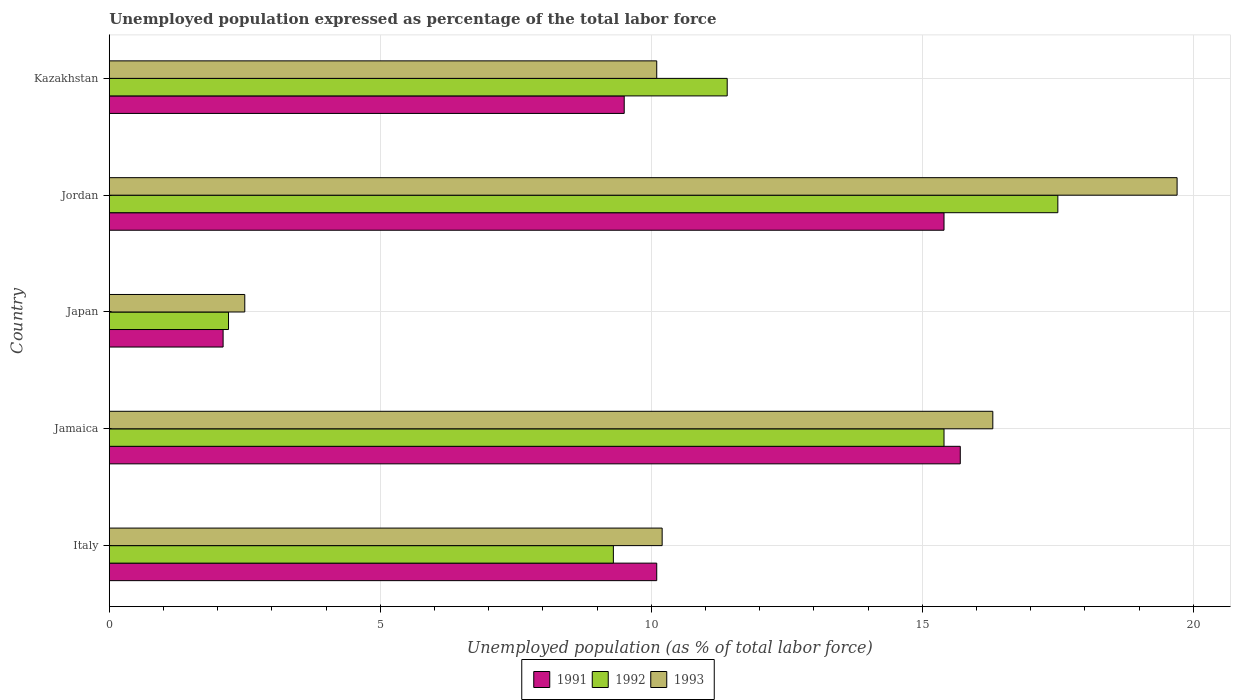How many different coloured bars are there?
Your answer should be compact. 3. How many groups of bars are there?
Keep it short and to the point. 5. Are the number of bars per tick equal to the number of legend labels?
Your response must be concise. Yes. Are the number of bars on each tick of the Y-axis equal?
Provide a short and direct response. Yes. How many bars are there on the 4th tick from the top?
Provide a succinct answer. 3. How many bars are there on the 3rd tick from the bottom?
Provide a short and direct response. 3. What is the label of the 1st group of bars from the top?
Keep it short and to the point. Kazakhstan. In how many cases, is the number of bars for a given country not equal to the number of legend labels?
Keep it short and to the point. 0. What is the unemployment in in 1991 in Italy?
Keep it short and to the point. 10.1. Across all countries, what is the maximum unemployment in in 1991?
Your answer should be compact. 15.7. Across all countries, what is the minimum unemployment in in 1991?
Provide a succinct answer. 2.1. In which country was the unemployment in in 1991 maximum?
Offer a terse response. Jamaica. What is the total unemployment in in 1992 in the graph?
Give a very brief answer. 55.8. What is the difference between the unemployment in in 1993 in Italy and that in Japan?
Keep it short and to the point. 7.7. What is the difference between the unemployment in in 1991 in Italy and the unemployment in in 1993 in Japan?
Provide a short and direct response. 7.6. What is the average unemployment in in 1993 per country?
Make the answer very short. 11.76. What is the difference between the unemployment in in 1992 and unemployment in in 1991 in Jamaica?
Offer a very short reply. -0.3. What is the ratio of the unemployment in in 1992 in Italy to that in Kazakhstan?
Offer a very short reply. 0.82. Is the unemployment in in 1992 in Japan less than that in Kazakhstan?
Offer a terse response. Yes. What is the difference between the highest and the second highest unemployment in in 1992?
Make the answer very short. 2.1. What is the difference between the highest and the lowest unemployment in in 1991?
Provide a short and direct response. 13.6. In how many countries, is the unemployment in in 1993 greater than the average unemployment in in 1993 taken over all countries?
Ensure brevity in your answer.  2. Is the sum of the unemployment in in 1991 in Japan and Jordan greater than the maximum unemployment in in 1992 across all countries?
Your answer should be very brief. No. What does the 3rd bar from the bottom in Kazakhstan represents?
Make the answer very short. 1993. Is it the case that in every country, the sum of the unemployment in in 1993 and unemployment in in 1992 is greater than the unemployment in in 1991?
Offer a very short reply. Yes. How many bars are there?
Make the answer very short. 15. Are all the bars in the graph horizontal?
Your response must be concise. Yes. How many countries are there in the graph?
Your answer should be very brief. 5. Does the graph contain any zero values?
Your response must be concise. No. Does the graph contain grids?
Give a very brief answer. Yes. Where does the legend appear in the graph?
Give a very brief answer. Bottom center. How many legend labels are there?
Make the answer very short. 3. How are the legend labels stacked?
Provide a succinct answer. Horizontal. What is the title of the graph?
Provide a short and direct response. Unemployed population expressed as percentage of the total labor force. Does "1986" appear as one of the legend labels in the graph?
Provide a succinct answer. No. What is the label or title of the X-axis?
Your answer should be compact. Unemployed population (as % of total labor force). What is the label or title of the Y-axis?
Keep it short and to the point. Country. What is the Unemployed population (as % of total labor force) of 1991 in Italy?
Offer a very short reply. 10.1. What is the Unemployed population (as % of total labor force) of 1992 in Italy?
Give a very brief answer. 9.3. What is the Unemployed population (as % of total labor force) of 1993 in Italy?
Your answer should be very brief. 10.2. What is the Unemployed population (as % of total labor force) in 1991 in Jamaica?
Offer a terse response. 15.7. What is the Unemployed population (as % of total labor force) in 1992 in Jamaica?
Provide a succinct answer. 15.4. What is the Unemployed population (as % of total labor force) in 1993 in Jamaica?
Provide a succinct answer. 16.3. What is the Unemployed population (as % of total labor force) in 1991 in Japan?
Ensure brevity in your answer.  2.1. What is the Unemployed population (as % of total labor force) in 1992 in Japan?
Offer a terse response. 2.2. What is the Unemployed population (as % of total labor force) in 1991 in Jordan?
Offer a very short reply. 15.4. What is the Unemployed population (as % of total labor force) in 1992 in Jordan?
Offer a terse response. 17.5. What is the Unemployed population (as % of total labor force) in 1993 in Jordan?
Your answer should be compact. 19.7. What is the Unemployed population (as % of total labor force) of 1991 in Kazakhstan?
Keep it short and to the point. 9.5. What is the Unemployed population (as % of total labor force) of 1992 in Kazakhstan?
Offer a terse response. 11.4. What is the Unemployed population (as % of total labor force) in 1993 in Kazakhstan?
Keep it short and to the point. 10.1. Across all countries, what is the maximum Unemployed population (as % of total labor force) of 1991?
Provide a succinct answer. 15.7. Across all countries, what is the maximum Unemployed population (as % of total labor force) in 1992?
Your answer should be very brief. 17.5. Across all countries, what is the maximum Unemployed population (as % of total labor force) of 1993?
Ensure brevity in your answer.  19.7. Across all countries, what is the minimum Unemployed population (as % of total labor force) of 1991?
Provide a succinct answer. 2.1. Across all countries, what is the minimum Unemployed population (as % of total labor force) in 1992?
Offer a terse response. 2.2. What is the total Unemployed population (as % of total labor force) in 1991 in the graph?
Provide a short and direct response. 52.8. What is the total Unemployed population (as % of total labor force) in 1992 in the graph?
Give a very brief answer. 55.8. What is the total Unemployed population (as % of total labor force) of 1993 in the graph?
Offer a very short reply. 58.8. What is the difference between the Unemployed population (as % of total labor force) in 1991 in Italy and that in Jamaica?
Give a very brief answer. -5.6. What is the difference between the Unemployed population (as % of total labor force) of 1991 in Italy and that in Japan?
Ensure brevity in your answer.  8. What is the difference between the Unemployed population (as % of total labor force) of 1992 in Italy and that in Japan?
Offer a terse response. 7.1. What is the difference between the Unemployed population (as % of total labor force) of 1992 in Italy and that in Kazakhstan?
Your answer should be very brief. -2.1. What is the difference between the Unemployed population (as % of total labor force) in 1993 in Italy and that in Kazakhstan?
Provide a succinct answer. 0.1. What is the difference between the Unemployed population (as % of total labor force) in 1991 in Jamaica and that in Japan?
Ensure brevity in your answer.  13.6. What is the difference between the Unemployed population (as % of total labor force) in 1993 in Jamaica and that in Japan?
Your response must be concise. 13.8. What is the difference between the Unemployed population (as % of total labor force) in 1992 in Jamaica and that in Kazakhstan?
Provide a short and direct response. 4. What is the difference between the Unemployed population (as % of total labor force) of 1992 in Japan and that in Jordan?
Your response must be concise. -15.3. What is the difference between the Unemployed population (as % of total labor force) in 1993 in Japan and that in Jordan?
Ensure brevity in your answer.  -17.2. What is the difference between the Unemployed population (as % of total labor force) of 1991 in Japan and that in Kazakhstan?
Your answer should be very brief. -7.4. What is the difference between the Unemployed population (as % of total labor force) in 1993 in Jordan and that in Kazakhstan?
Make the answer very short. 9.6. What is the difference between the Unemployed population (as % of total labor force) in 1991 in Italy and the Unemployed population (as % of total labor force) in 1992 in Jamaica?
Provide a succinct answer. -5.3. What is the difference between the Unemployed population (as % of total labor force) in 1991 in Italy and the Unemployed population (as % of total labor force) in 1993 in Jamaica?
Give a very brief answer. -6.2. What is the difference between the Unemployed population (as % of total labor force) of 1991 in Italy and the Unemployed population (as % of total labor force) of 1992 in Japan?
Your answer should be very brief. 7.9. What is the difference between the Unemployed population (as % of total labor force) in 1991 in Italy and the Unemployed population (as % of total labor force) in 1993 in Japan?
Your answer should be compact. 7.6. What is the difference between the Unemployed population (as % of total labor force) of 1992 in Italy and the Unemployed population (as % of total labor force) of 1993 in Japan?
Provide a succinct answer. 6.8. What is the difference between the Unemployed population (as % of total labor force) in 1991 in Italy and the Unemployed population (as % of total labor force) in 1992 in Jordan?
Offer a very short reply. -7.4. What is the difference between the Unemployed population (as % of total labor force) of 1992 in Italy and the Unemployed population (as % of total labor force) of 1993 in Jordan?
Provide a short and direct response. -10.4. What is the difference between the Unemployed population (as % of total labor force) in 1991 in Italy and the Unemployed population (as % of total labor force) in 1993 in Kazakhstan?
Make the answer very short. 0. What is the difference between the Unemployed population (as % of total labor force) in 1991 in Jamaica and the Unemployed population (as % of total labor force) in 1993 in Japan?
Offer a very short reply. 13.2. What is the difference between the Unemployed population (as % of total labor force) in 1992 in Jamaica and the Unemployed population (as % of total labor force) in 1993 in Japan?
Offer a terse response. 12.9. What is the difference between the Unemployed population (as % of total labor force) in 1991 in Jamaica and the Unemployed population (as % of total labor force) in 1993 in Jordan?
Your answer should be compact. -4. What is the difference between the Unemployed population (as % of total labor force) of 1992 in Jamaica and the Unemployed population (as % of total labor force) of 1993 in Jordan?
Keep it short and to the point. -4.3. What is the difference between the Unemployed population (as % of total labor force) in 1992 in Jamaica and the Unemployed population (as % of total labor force) in 1993 in Kazakhstan?
Provide a short and direct response. 5.3. What is the difference between the Unemployed population (as % of total labor force) of 1991 in Japan and the Unemployed population (as % of total labor force) of 1992 in Jordan?
Your answer should be very brief. -15.4. What is the difference between the Unemployed population (as % of total labor force) in 1991 in Japan and the Unemployed population (as % of total labor force) in 1993 in Jordan?
Give a very brief answer. -17.6. What is the difference between the Unemployed population (as % of total labor force) in 1992 in Japan and the Unemployed population (as % of total labor force) in 1993 in Jordan?
Make the answer very short. -17.5. What is the difference between the Unemployed population (as % of total labor force) in 1991 in Japan and the Unemployed population (as % of total labor force) in 1993 in Kazakhstan?
Provide a succinct answer. -8. What is the difference between the Unemployed population (as % of total labor force) in 1991 in Jordan and the Unemployed population (as % of total labor force) in 1992 in Kazakhstan?
Your answer should be compact. 4. What is the difference between the Unemployed population (as % of total labor force) in 1992 in Jordan and the Unemployed population (as % of total labor force) in 1993 in Kazakhstan?
Provide a short and direct response. 7.4. What is the average Unemployed population (as % of total labor force) of 1991 per country?
Offer a very short reply. 10.56. What is the average Unemployed population (as % of total labor force) in 1992 per country?
Your answer should be very brief. 11.16. What is the average Unemployed population (as % of total labor force) in 1993 per country?
Your answer should be very brief. 11.76. What is the difference between the Unemployed population (as % of total labor force) of 1991 and Unemployed population (as % of total labor force) of 1992 in Italy?
Offer a terse response. 0.8. What is the difference between the Unemployed population (as % of total labor force) in 1991 and Unemployed population (as % of total labor force) in 1993 in Italy?
Ensure brevity in your answer.  -0.1. What is the difference between the Unemployed population (as % of total labor force) of 1992 and Unemployed population (as % of total labor force) of 1993 in Italy?
Your response must be concise. -0.9. What is the difference between the Unemployed population (as % of total labor force) in 1991 and Unemployed population (as % of total labor force) in 1992 in Jamaica?
Provide a short and direct response. 0.3. What is the difference between the Unemployed population (as % of total labor force) of 1991 and Unemployed population (as % of total labor force) of 1993 in Jamaica?
Your answer should be very brief. -0.6. What is the difference between the Unemployed population (as % of total labor force) in 1992 and Unemployed population (as % of total labor force) in 1993 in Jamaica?
Offer a very short reply. -0.9. What is the difference between the Unemployed population (as % of total labor force) in 1991 and Unemployed population (as % of total labor force) in 1992 in Japan?
Give a very brief answer. -0.1. What is the difference between the Unemployed population (as % of total labor force) of 1991 and Unemployed population (as % of total labor force) of 1993 in Japan?
Make the answer very short. -0.4. What is the difference between the Unemployed population (as % of total labor force) in 1991 and Unemployed population (as % of total labor force) in 1992 in Jordan?
Your response must be concise. -2.1. What is the difference between the Unemployed population (as % of total labor force) in 1992 and Unemployed population (as % of total labor force) in 1993 in Jordan?
Keep it short and to the point. -2.2. What is the difference between the Unemployed population (as % of total labor force) of 1991 and Unemployed population (as % of total labor force) of 1992 in Kazakhstan?
Provide a succinct answer. -1.9. What is the difference between the Unemployed population (as % of total labor force) of 1991 and Unemployed population (as % of total labor force) of 1993 in Kazakhstan?
Give a very brief answer. -0.6. What is the difference between the Unemployed population (as % of total labor force) in 1992 and Unemployed population (as % of total labor force) in 1993 in Kazakhstan?
Your answer should be very brief. 1.3. What is the ratio of the Unemployed population (as % of total labor force) of 1991 in Italy to that in Jamaica?
Make the answer very short. 0.64. What is the ratio of the Unemployed population (as % of total labor force) in 1992 in Italy to that in Jamaica?
Provide a succinct answer. 0.6. What is the ratio of the Unemployed population (as % of total labor force) in 1993 in Italy to that in Jamaica?
Offer a very short reply. 0.63. What is the ratio of the Unemployed population (as % of total labor force) in 1991 in Italy to that in Japan?
Your answer should be very brief. 4.81. What is the ratio of the Unemployed population (as % of total labor force) of 1992 in Italy to that in Japan?
Offer a very short reply. 4.23. What is the ratio of the Unemployed population (as % of total labor force) in 1993 in Italy to that in Japan?
Your answer should be very brief. 4.08. What is the ratio of the Unemployed population (as % of total labor force) of 1991 in Italy to that in Jordan?
Your answer should be very brief. 0.66. What is the ratio of the Unemployed population (as % of total labor force) of 1992 in Italy to that in Jordan?
Provide a succinct answer. 0.53. What is the ratio of the Unemployed population (as % of total labor force) in 1993 in Italy to that in Jordan?
Provide a succinct answer. 0.52. What is the ratio of the Unemployed population (as % of total labor force) in 1991 in Italy to that in Kazakhstan?
Make the answer very short. 1.06. What is the ratio of the Unemployed population (as % of total labor force) of 1992 in Italy to that in Kazakhstan?
Offer a very short reply. 0.82. What is the ratio of the Unemployed population (as % of total labor force) of 1993 in Italy to that in Kazakhstan?
Ensure brevity in your answer.  1.01. What is the ratio of the Unemployed population (as % of total labor force) in 1991 in Jamaica to that in Japan?
Give a very brief answer. 7.48. What is the ratio of the Unemployed population (as % of total labor force) in 1992 in Jamaica to that in Japan?
Offer a very short reply. 7. What is the ratio of the Unemployed population (as % of total labor force) in 1993 in Jamaica to that in Japan?
Give a very brief answer. 6.52. What is the ratio of the Unemployed population (as % of total labor force) in 1991 in Jamaica to that in Jordan?
Provide a short and direct response. 1.02. What is the ratio of the Unemployed population (as % of total labor force) in 1993 in Jamaica to that in Jordan?
Your answer should be compact. 0.83. What is the ratio of the Unemployed population (as % of total labor force) of 1991 in Jamaica to that in Kazakhstan?
Offer a very short reply. 1.65. What is the ratio of the Unemployed population (as % of total labor force) in 1992 in Jamaica to that in Kazakhstan?
Offer a very short reply. 1.35. What is the ratio of the Unemployed population (as % of total labor force) in 1993 in Jamaica to that in Kazakhstan?
Your answer should be compact. 1.61. What is the ratio of the Unemployed population (as % of total labor force) of 1991 in Japan to that in Jordan?
Offer a terse response. 0.14. What is the ratio of the Unemployed population (as % of total labor force) in 1992 in Japan to that in Jordan?
Keep it short and to the point. 0.13. What is the ratio of the Unemployed population (as % of total labor force) in 1993 in Japan to that in Jordan?
Provide a succinct answer. 0.13. What is the ratio of the Unemployed population (as % of total labor force) in 1991 in Japan to that in Kazakhstan?
Keep it short and to the point. 0.22. What is the ratio of the Unemployed population (as % of total labor force) in 1992 in Japan to that in Kazakhstan?
Offer a very short reply. 0.19. What is the ratio of the Unemployed population (as % of total labor force) of 1993 in Japan to that in Kazakhstan?
Your response must be concise. 0.25. What is the ratio of the Unemployed population (as % of total labor force) of 1991 in Jordan to that in Kazakhstan?
Make the answer very short. 1.62. What is the ratio of the Unemployed population (as % of total labor force) in 1992 in Jordan to that in Kazakhstan?
Offer a very short reply. 1.54. What is the ratio of the Unemployed population (as % of total labor force) in 1993 in Jordan to that in Kazakhstan?
Make the answer very short. 1.95. What is the difference between the highest and the second highest Unemployed population (as % of total labor force) of 1991?
Your answer should be very brief. 0.3. What is the difference between the highest and the lowest Unemployed population (as % of total labor force) of 1991?
Offer a terse response. 13.6. What is the difference between the highest and the lowest Unemployed population (as % of total labor force) in 1992?
Ensure brevity in your answer.  15.3. 